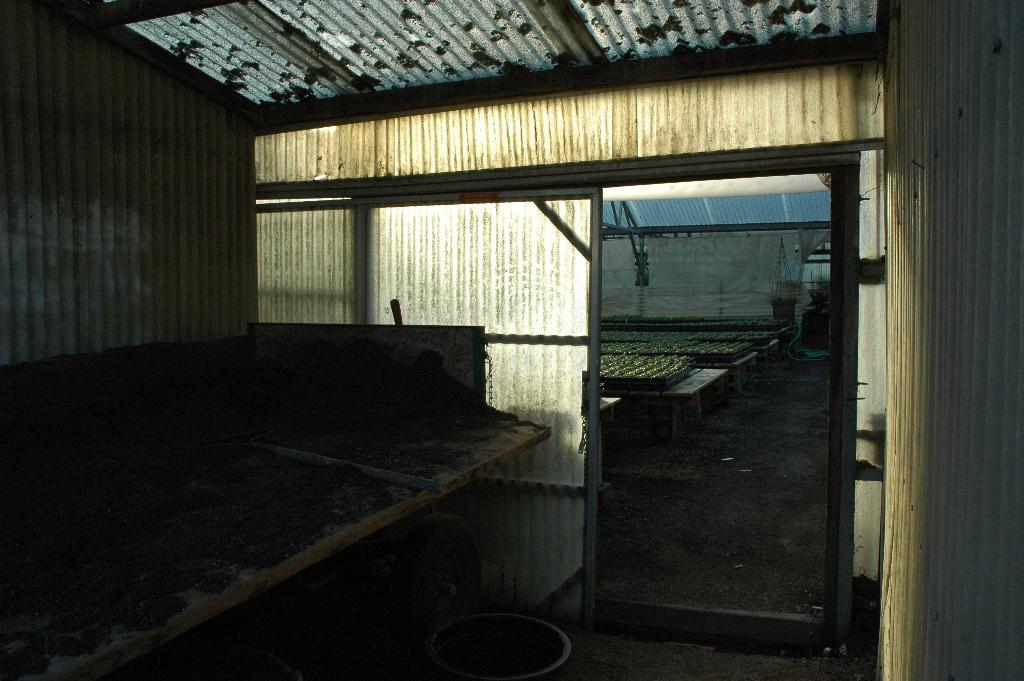What type of structure is depicted in the image? There is a closed place in the image that resembles a shed. Can you describe the appearance of the structure? The structure appears to be a shed, which is typically used for storage or shelter. Who is the representative of the quilt in the image? There is no quilt or representative present in the image. 